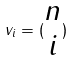<formula> <loc_0><loc_0><loc_500><loc_500>v _ { i } = ( \begin{matrix} n \\ i \end{matrix} )</formula> 